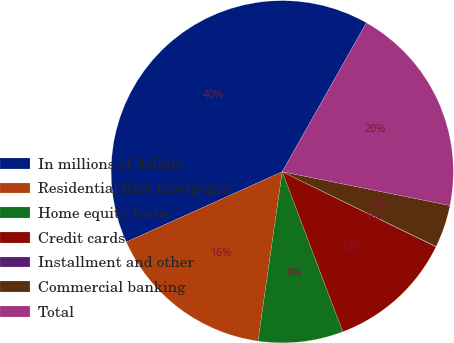Convert chart. <chart><loc_0><loc_0><loc_500><loc_500><pie_chart><fcel>In millions of dollars<fcel>Residential first mortgages<fcel>Home equity loans<fcel>Credit cards<fcel>Installment and other<fcel>Commercial banking<fcel>Total<nl><fcel>39.93%<fcel>16.0%<fcel>8.02%<fcel>12.01%<fcel>0.04%<fcel>4.03%<fcel>19.98%<nl></chart> 